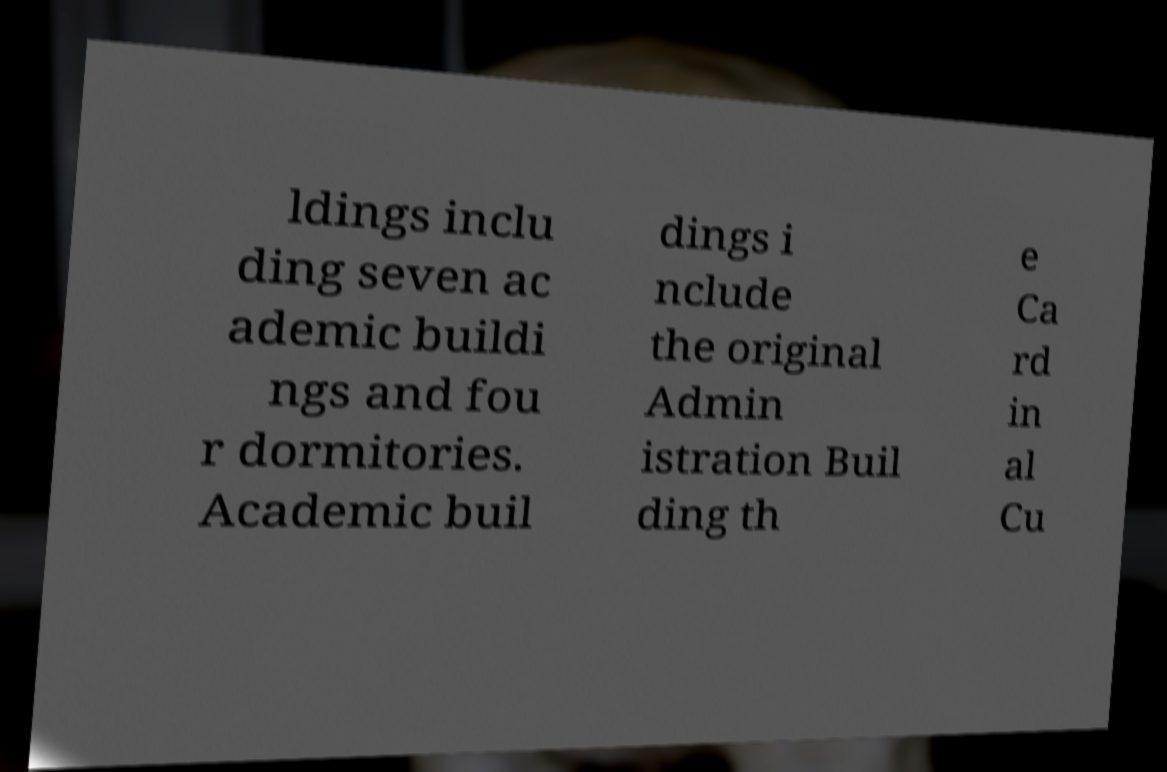Please identify and transcribe the text found in this image. ldings inclu ding seven ac ademic buildi ngs and fou r dormitories. Academic buil dings i nclude the original Admin istration Buil ding th e Ca rd in al Cu 